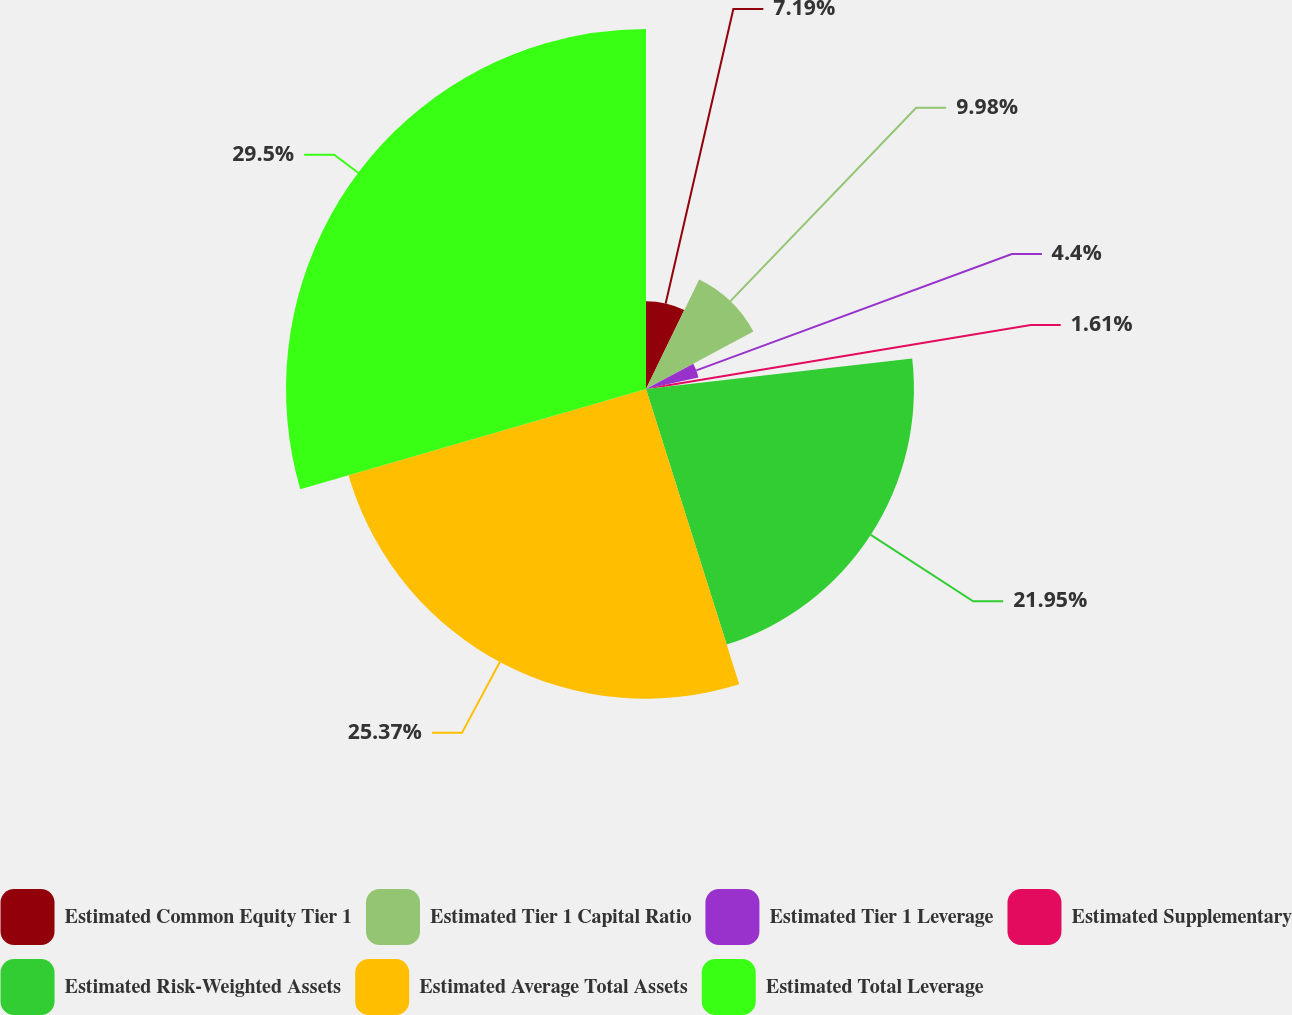Convert chart to OTSL. <chart><loc_0><loc_0><loc_500><loc_500><pie_chart><fcel>Estimated Common Equity Tier 1<fcel>Estimated Tier 1 Capital Ratio<fcel>Estimated Tier 1 Leverage<fcel>Estimated Supplementary<fcel>Estimated Risk-Weighted Assets<fcel>Estimated Average Total Assets<fcel>Estimated Total Leverage<nl><fcel>7.19%<fcel>9.98%<fcel>4.4%<fcel>1.61%<fcel>21.95%<fcel>25.37%<fcel>29.49%<nl></chart> 